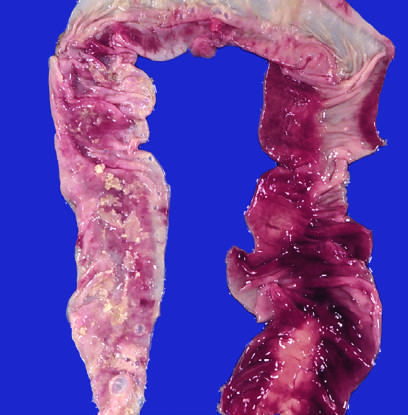what does the congested portion of the ileum correspond to?
Answer the question using a single word or phrase. Areas of hemorrhagic infarction and transmural necrosis 